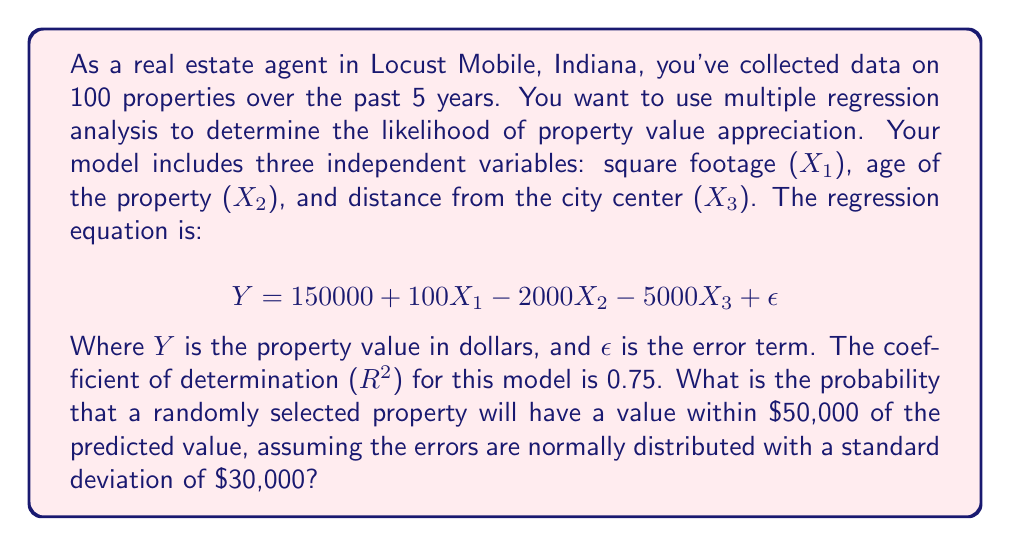Can you solve this math problem? To solve this problem, we'll follow these steps:

1) First, recall that R² represents the proportion of variance in the dependent variable (Y) that is predictable from the independent variables (X1, X2, X3). Given R² = 0.75, this means our model accounts for 75% of the variability in property values.

2) The standard error of the estimate (SEE) represents the average distance between the observed values and the regression line. We can calculate it using the standard deviation of the errors:

   $$SEE = \frac{SD}{\sqrt{1-R^2}} = \frac{30000}{\sqrt{1-0.75}} = 60000$$

3) Now, we want to find the probability that a randomly selected property will have a value within $50,000 of the predicted value. This is equivalent to finding the probability that the error is within ±$50,000.

4) We can standardize this range using the z-score formula:

   $$z = \frac{X - \mu}{\sigma}$$

   Where X is our range ($50,000), μ is the mean of the errors (0, as errors are assumed to be normally distributed around 0), and σ is our SEE ($60,000).

5) Calculate the z-scores:

   $$z_{lower} = \frac{-50000 - 0}{60000} = -0.833$$
   $$z_{upper} = \frac{50000 - 0}{60000} = 0.833$$

6) The probability we're looking for is the area between these two z-scores in a standard normal distribution. We can find this using a standard normal table or a calculator:

   $$P(-0.833 < Z < 0.833) = 2 * P(Z < 0.833) - 1 = 2 * 0.7976 - 1 = 0.5952$$

Therefore, the probability that a randomly selected property will have a value within $50,000 of the predicted value is approximately 0.5952 or 59.52%.
Answer: 0.5952 